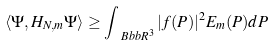<formula> <loc_0><loc_0><loc_500><loc_500>\langle \Psi , H _ { N , m } \Psi \rangle \geq \int _ { \ B b b R ^ { 3 } } | f ( P ) | ^ { 2 } E _ { m } ( P ) d P</formula> 